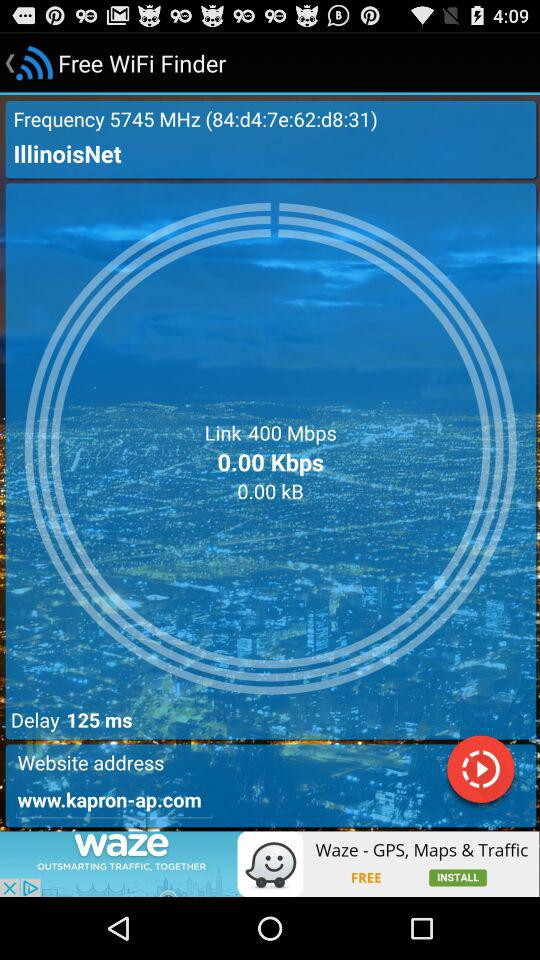What is the speed of the connection? The speed of the connection is 0 kbps. 